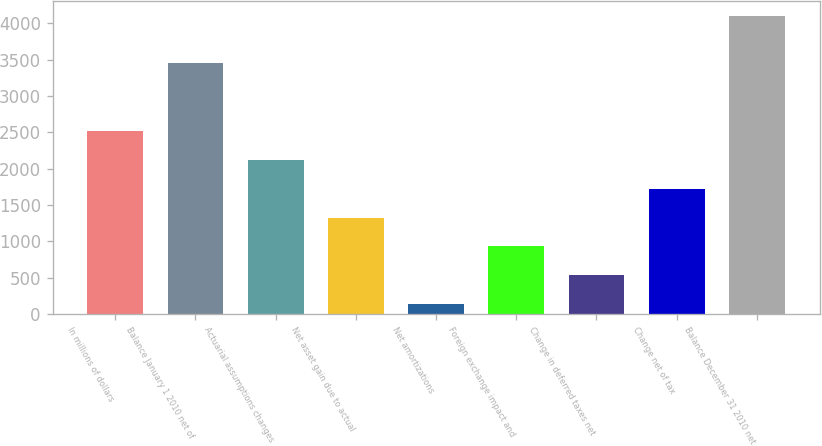Convert chart to OTSL. <chart><loc_0><loc_0><loc_500><loc_500><bar_chart><fcel>In millions of dollars<fcel>Balance January 1 2010 net of<fcel>Actuarial assumptions changes<fcel>Net asset gain due to actual<fcel>Net amortizations<fcel>Foreign exchange impact and<fcel>Change in deferred taxes net<fcel>Change net of tax<fcel>Balance December 31 2010 net<nl><fcel>2517.8<fcel>3461<fcel>2121<fcel>1327.4<fcel>137<fcel>930.6<fcel>533.8<fcel>1724.2<fcel>4105<nl></chart> 